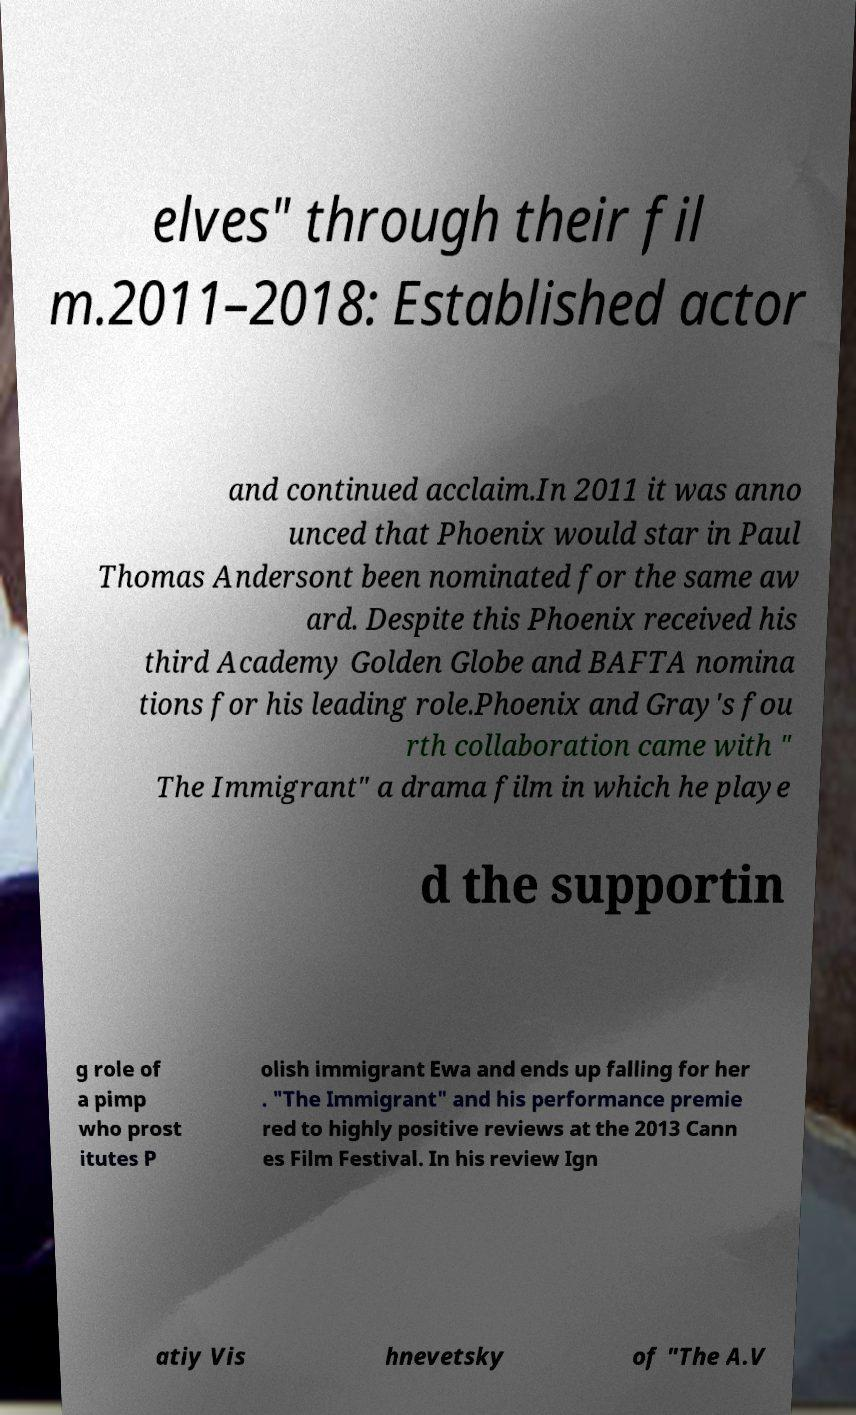For documentation purposes, I need the text within this image transcribed. Could you provide that? elves" through their fil m.2011–2018: Established actor and continued acclaim.In 2011 it was anno unced that Phoenix would star in Paul Thomas Andersont been nominated for the same aw ard. Despite this Phoenix received his third Academy Golden Globe and BAFTA nomina tions for his leading role.Phoenix and Gray's fou rth collaboration came with " The Immigrant" a drama film in which he playe d the supportin g role of a pimp who prost itutes P olish immigrant Ewa and ends up falling for her . "The Immigrant" and his performance premie red to highly positive reviews at the 2013 Cann es Film Festival. In his review Ign atiy Vis hnevetsky of "The A.V 